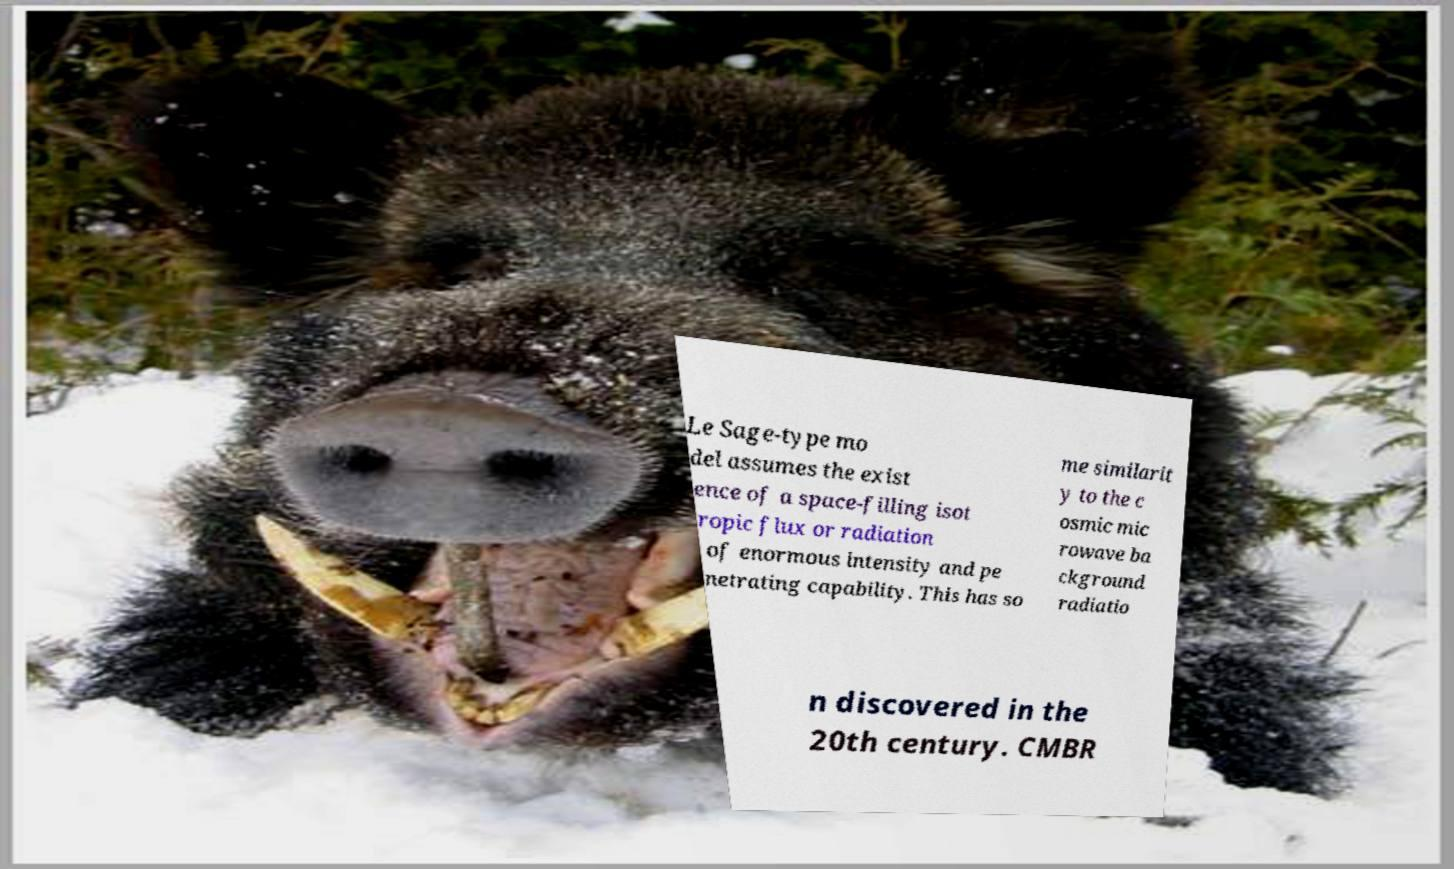There's text embedded in this image that I need extracted. Can you transcribe it verbatim? Le Sage-type mo del assumes the exist ence of a space-filling isot ropic flux or radiation of enormous intensity and pe netrating capability. This has so me similarit y to the c osmic mic rowave ba ckground radiatio n discovered in the 20th century. CMBR 